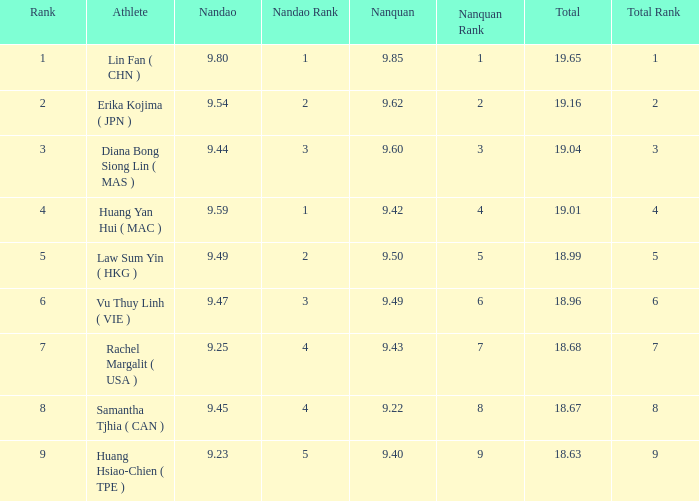Which Nanquan has a Nandao smaller than 9.44, and a Rank smaller than 9, and a Total larger than 18.68? None. 